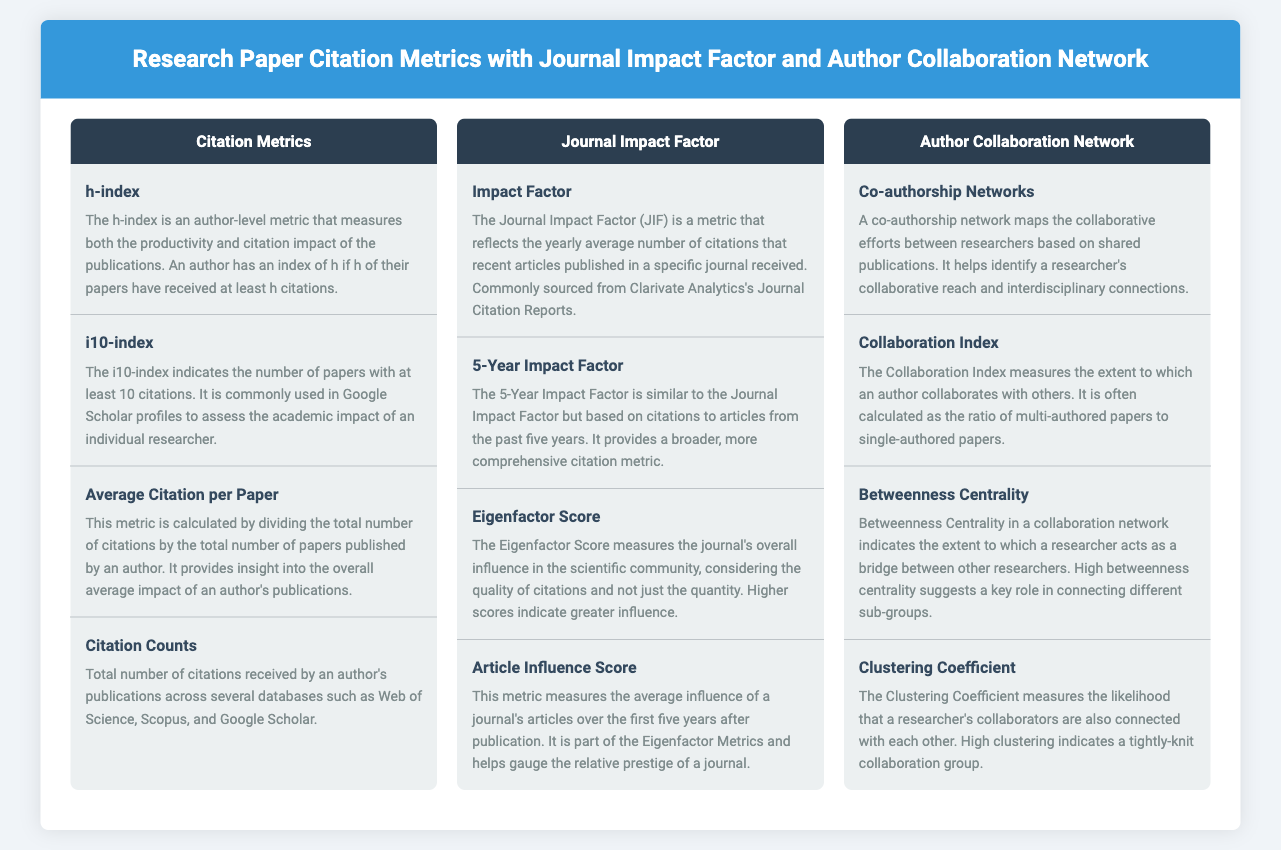What is the h-index? The h-index is an author-level metric that measures both the productivity and citation impact of the publications.
Answer: Author-level metric What does the i10-index indicate? The i10-index indicates the number of papers with at least 10 citations.
Answer: Number of papers with at least 10 citations What does the Average Citation per Paper measure? This metric provides insight into the overall average impact of an author's publications.
Answer: Overall average impact What is the 5-Year Impact Factor? The 5-Year Impact Factor is based on citations to articles from the past five years.
Answer: Based on citations from the past five years What does the Collaboration Index measure? The Collaboration Index measures the extent to which an author collaborates with others.
Answer: Extent of collaboration What is Betweenness Centrality? Betweenness Centrality indicates the extent to which a researcher acts as a bridge between other researchers.
Answer: Acts as a bridge What does a high Clustering Coefficient indicate? High clustering indicates a tightly-knit collaboration group.
Answer: Tightly-knit collaboration group What is the Journal Impact Factor? The Journal Impact Factor reflects the yearly average number of citations that recent articles published in a specific journal received.
Answer: Yearly average number of citations What does the Eigenfactor Score measure? The Eigenfactor Score measures the journal's overall influence in the scientific community.
Answer: Overall influence in the scientific community 